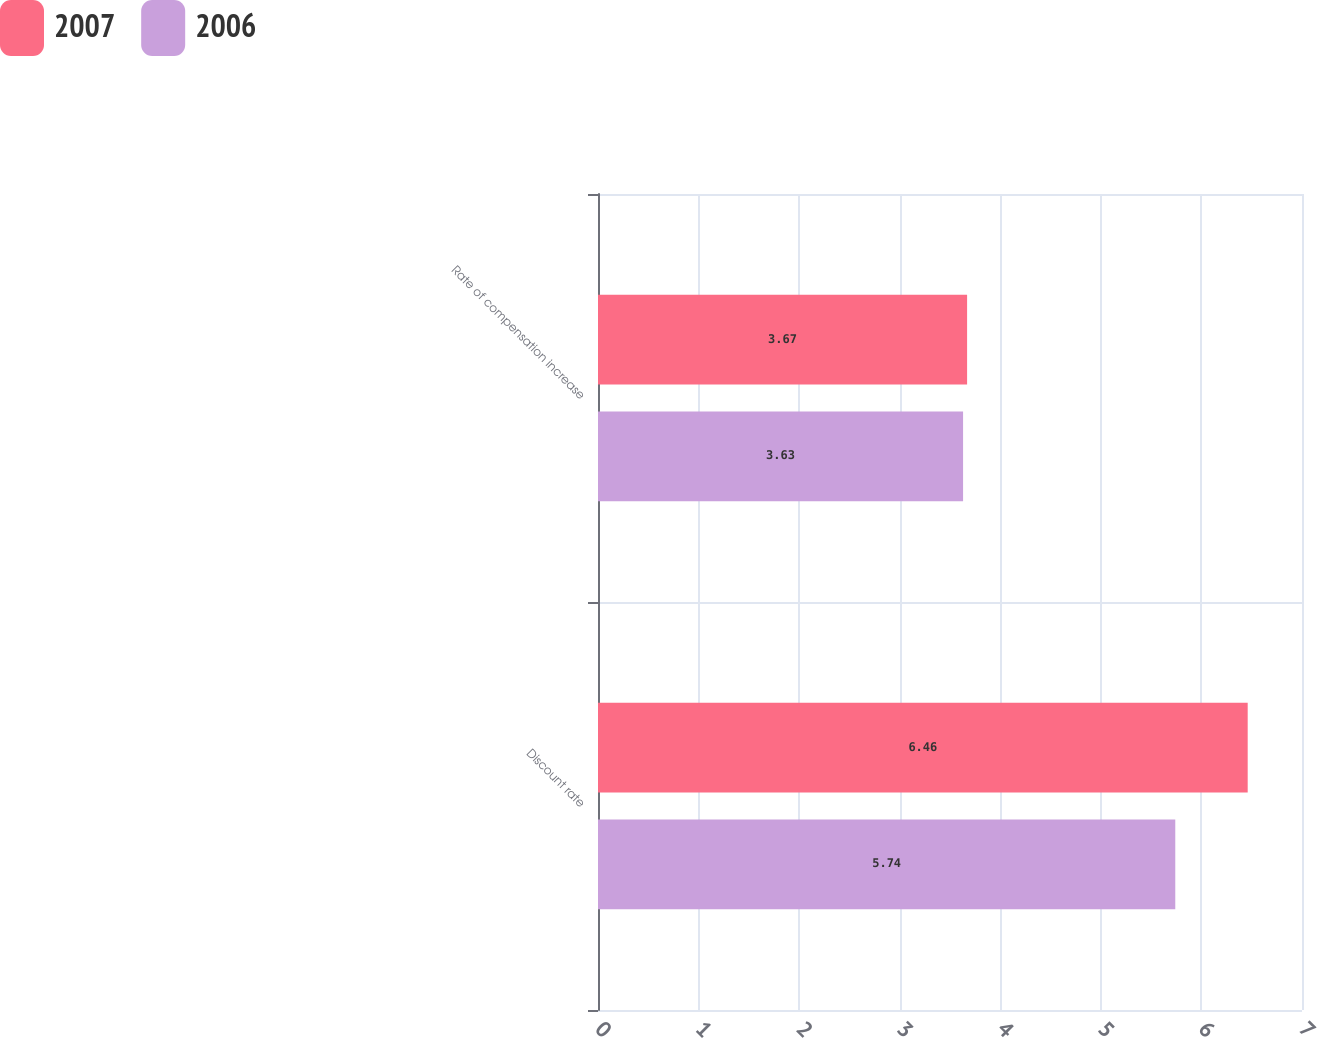Convert chart. <chart><loc_0><loc_0><loc_500><loc_500><stacked_bar_chart><ecel><fcel>Discount rate<fcel>Rate of compensation increase<nl><fcel>2007<fcel>6.46<fcel>3.67<nl><fcel>2006<fcel>5.74<fcel>3.63<nl></chart> 